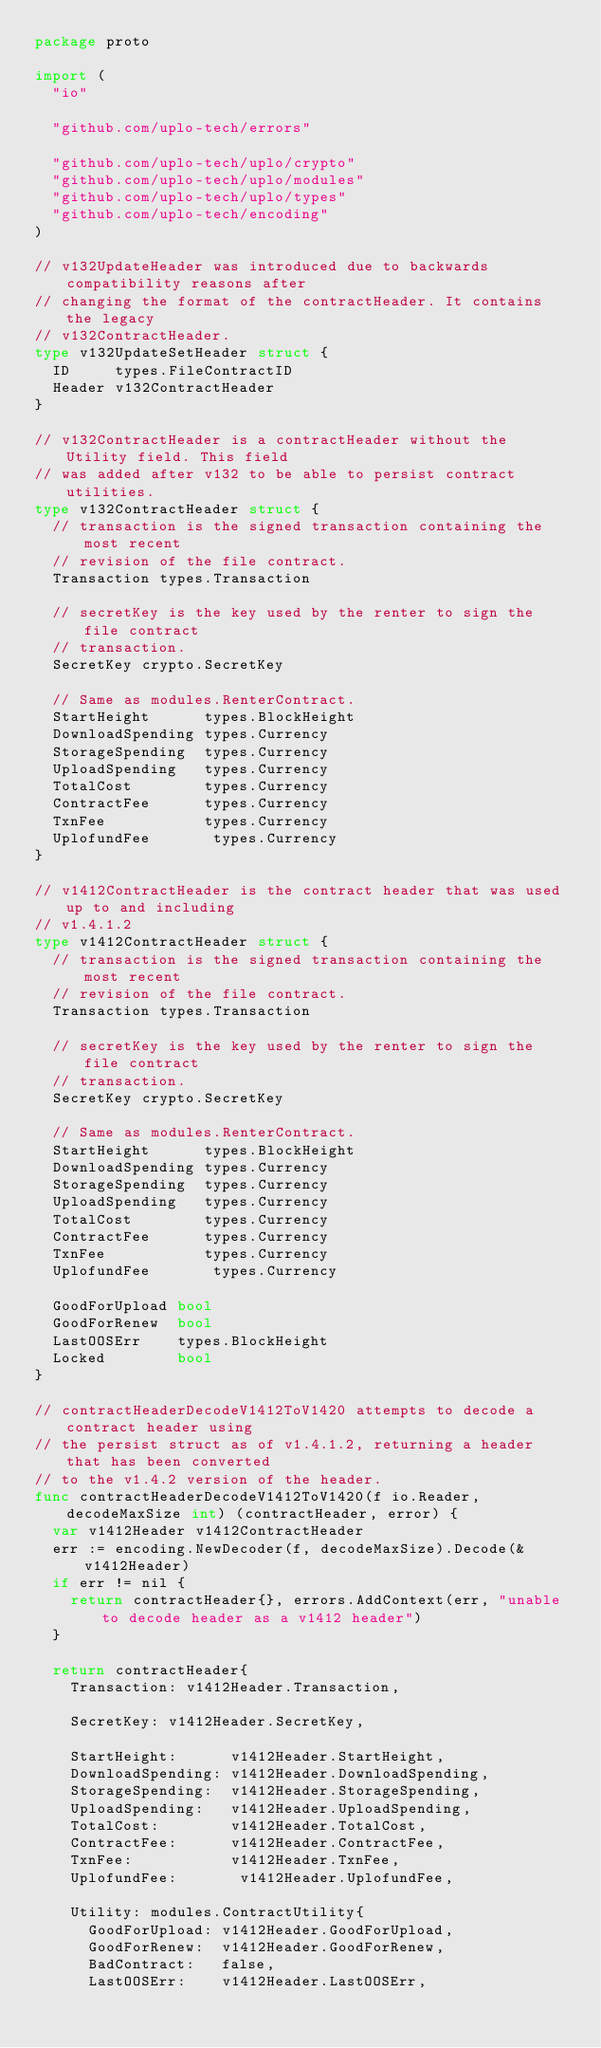<code> <loc_0><loc_0><loc_500><loc_500><_Go_>package proto

import (
	"io"

	"github.com/uplo-tech/errors"

	"github.com/uplo-tech/uplo/crypto"
	"github.com/uplo-tech/uplo/modules"
	"github.com/uplo-tech/uplo/types"
	"github.com/uplo-tech/encoding"
)

// v132UpdateHeader was introduced due to backwards compatibility reasons after
// changing the format of the contractHeader. It contains the legacy
// v132ContractHeader.
type v132UpdateSetHeader struct {
	ID     types.FileContractID
	Header v132ContractHeader
}

// v132ContractHeader is a contractHeader without the Utility field. This field
// was added after v132 to be able to persist contract utilities.
type v132ContractHeader struct {
	// transaction is the signed transaction containing the most recent
	// revision of the file contract.
	Transaction types.Transaction

	// secretKey is the key used by the renter to sign the file contract
	// transaction.
	SecretKey crypto.SecretKey

	// Same as modules.RenterContract.
	StartHeight      types.BlockHeight
	DownloadSpending types.Currency
	StorageSpending  types.Currency
	UploadSpending   types.Currency
	TotalCost        types.Currency
	ContractFee      types.Currency
	TxnFee           types.Currency
	UplofundFee       types.Currency
}

// v1412ContractHeader is the contract header that was used up to and including
// v1.4.1.2
type v1412ContractHeader struct {
	// transaction is the signed transaction containing the most recent
	// revision of the file contract.
	Transaction types.Transaction

	// secretKey is the key used by the renter to sign the file contract
	// transaction.
	SecretKey crypto.SecretKey

	// Same as modules.RenterContract.
	StartHeight      types.BlockHeight
	DownloadSpending types.Currency
	StorageSpending  types.Currency
	UploadSpending   types.Currency
	TotalCost        types.Currency
	ContractFee      types.Currency
	TxnFee           types.Currency
	UplofundFee       types.Currency

	GoodForUpload bool
	GoodForRenew  bool
	LastOOSErr    types.BlockHeight
	Locked        bool
}

// contractHeaderDecodeV1412ToV1420 attempts to decode a contract header using
// the persist struct as of v1.4.1.2, returning a header that has been converted
// to the v1.4.2 version of the header.
func contractHeaderDecodeV1412ToV1420(f io.Reader, decodeMaxSize int) (contractHeader, error) {
	var v1412Header v1412ContractHeader
	err := encoding.NewDecoder(f, decodeMaxSize).Decode(&v1412Header)
	if err != nil {
		return contractHeader{}, errors.AddContext(err, "unable to decode header as a v1412 header")
	}

	return contractHeader{
		Transaction: v1412Header.Transaction,

		SecretKey: v1412Header.SecretKey,

		StartHeight:      v1412Header.StartHeight,
		DownloadSpending: v1412Header.DownloadSpending,
		StorageSpending:  v1412Header.StorageSpending,
		UploadSpending:   v1412Header.UploadSpending,
		TotalCost:        v1412Header.TotalCost,
		ContractFee:      v1412Header.ContractFee,
		TxnFee:           v1412Header.TxnFee,
		UplofundFee:       v1412Header.UplofundFee,

		Utility: modules.ContractUtility{
			GoodForUpload: v1412Header.GoodForUpload,
			GoodForRenew:  v1412Header.GoodForRenew,
			BadContract:   false,
			LastOOSErr:    v1412Header.LastOOSErr,</code> 